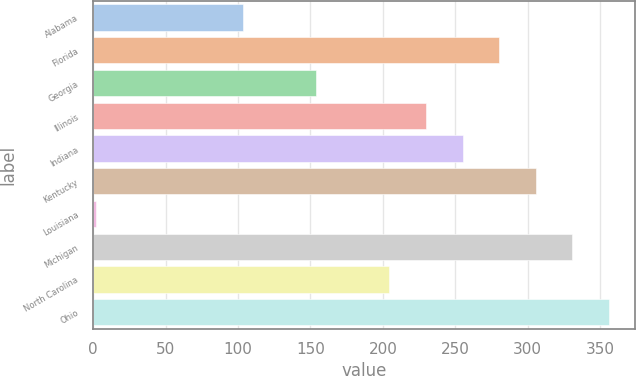<chart> <loc_0><loc_0><loc_500><loc_500><bar_chart><fcel>Alabama<fcel>Florida<fcel>Georgia<fcel>Illinois<fcel>Indiana<fcel>Kentucky<fcel>Louisiana<fcel>Michigan<fcel>North Carolina<fcel>Ohio<nl><fcel>103.2<fcel>280.3<fcel>153.8<fcel>229.7<fcel>255<fcel>305.6<fcel>2<fcel>330.9<fcel>204.4<fcel>356.2<nl></chart> 